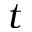<formula> <loc_0><loc_0><loc_500><loc_500>t</formula> 